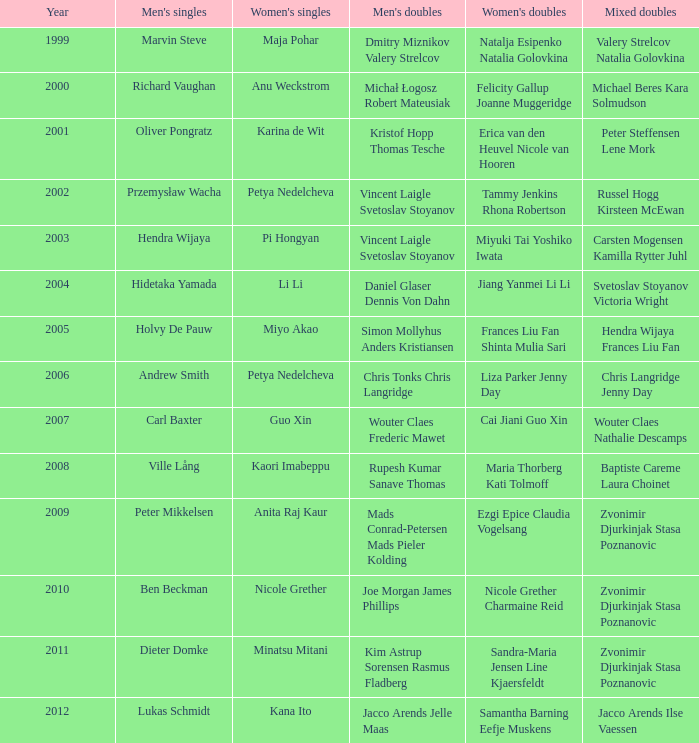Give the earliest year that featured Pi Hongyan on women's singles. 2003.0. 